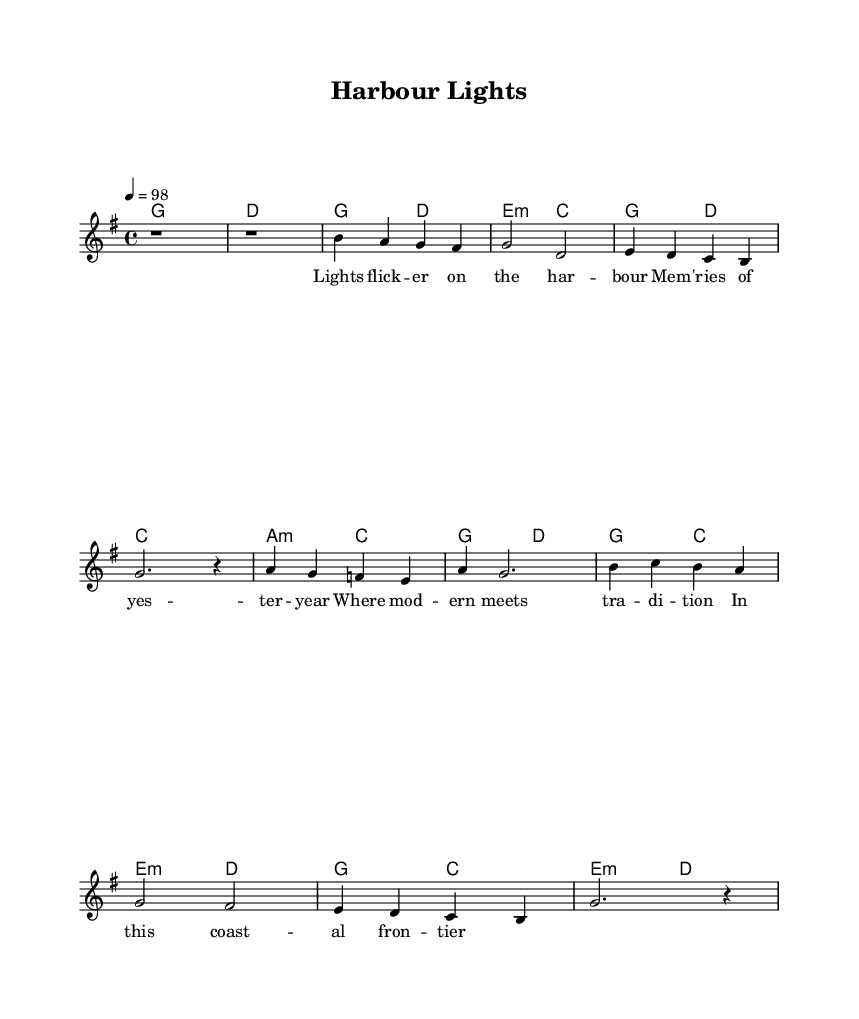What is the key signature of this music? The key signature is indicated by the sharp sign present on the staff. In this case, there are no sharps or flats, confirming it is G major.
Answer: G major What is the time signature of this piece? The time signature is found at the beginning of the score, represented as "4/4," which means there are four beats per measure.
Answer: 4/4 What is the tempo marking of the music? The tempo marking, indicated by "4 = 98," signifies that there are 98 beats per minute, providing a brisk pace.
Answer: 98 How many measures are in the verse section? By examining the melody, the verse is composed of four distinct measures, noted by the presence of bar lines separating them.
Answer: 4 What type of chords do we see mainly in the harmonies? The chords displayed consist primarily of major and minor chords, evident from the chord symbols like "g" for G major and "e:m" for E minor.
Answer: Major and minor What is the structure of the song as indicated in the sheet music? The sheet music structure can be deduced from the sections labeled as Verse, Pre-Chorus, and Chorus, which outlines the typical pop song form. The sequence of these sections presents a standard song structure.
Answer: Verse, Pre-Chorus, Chorus Which section includes the lyrics "Lights flick -- er on the har -- bour"? The lyrics in question are the opening lines of the Verse section, as reflected in the designated lyric alignment beneath the melody notation for that part of the song.
Answer: Verse 